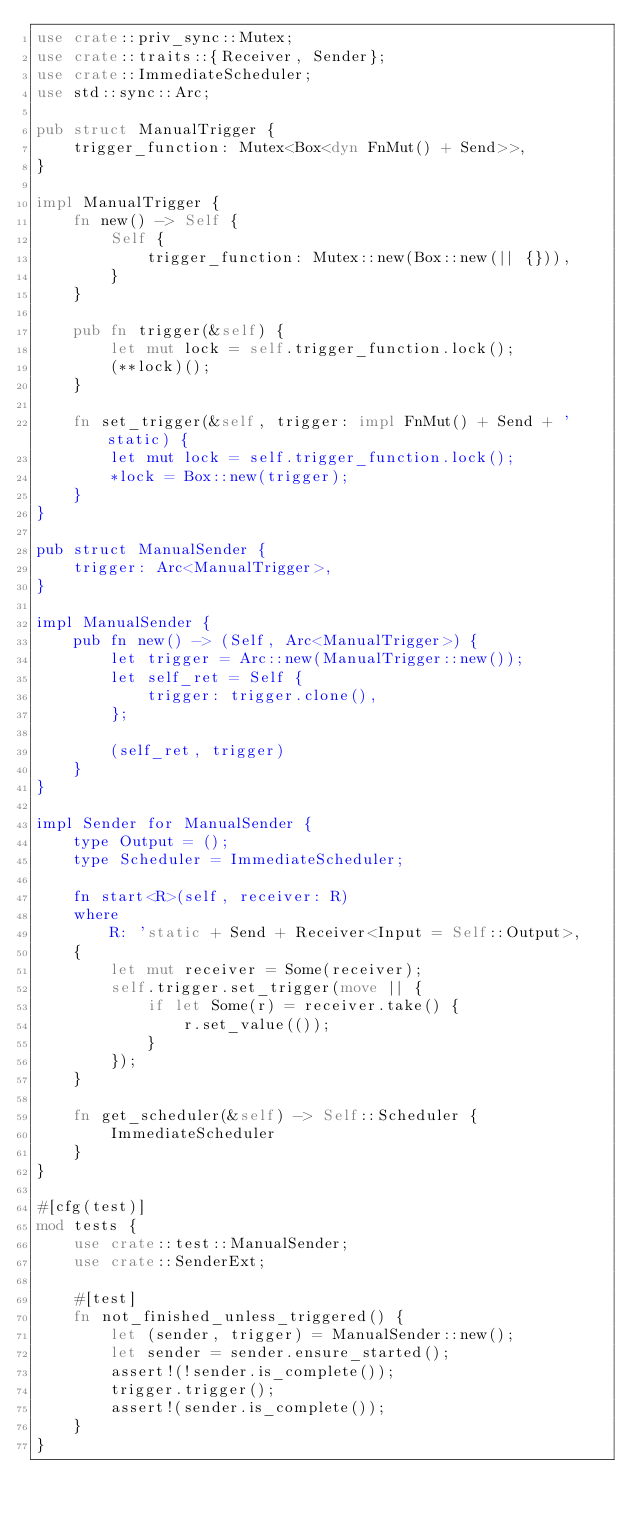Convert code to text. <code><loc_0><loc_0><loc_500><loc_500><_Rust_>use crate::priv_sync::Mutex;
use crate::traits::{Receiver, Sender};
use crate::ImmediateScheduler;
use std::sync::Arc;

pub struct ManualTrigger {
    trigger_function: Mutex<Box<dyn FnMut() + Send>>,
}

impl ManualTrigger {
    fn new() -> Self {
        Self {
            trigger_function: Mutex::new(Box::new(|| {})),
        }
    }

    pub fn trigger(&self) {
        let mut lock = self.trigger_function.lock();
        (**lock)();
    }

    fn set_trigger(&self, trigger: impl FnMut() + Send + 'static) {
        let mut lock = self.trigger_function.lock();
        *lock = Box::new(trigger);
    }
}

pub struct ManualSender {
    trigger: Arc<ManualTrigger>,
}

impl ManualSender {
    pub fn new() -> (Self, Arc<ManualTrigger>) {
        let trigger = Arc::new(ManualTrigger::new());
        let self_ret = Self {
            trigger: trigger.clone(),
        };

        (self_ret, trigger)
    }
}

impl Sender for ManualSender {
    type Output = ();
    type Scheduler = ImmediateScheduler;

    fn start<R>(self, receiver: R)
    where
        R: 'static + Send + Receiver<Input = Self::Output>,
    {
        let mut receiver = Some(receiver);
        self.trigger.set_trigger(move || {
            if let Some(r) = receiver.take() {
                r.set_value(());
            }
        });
    }

    fn get_scheduler(&self) -> Self::Scheduler {
        ImmediateScheduler
    }
}

#[cfg(test)]
mod tests {
    use crate::test::ManualSender;
    use crate::SenderExt;

    #[test]
    fn not_finished_unless_triggered() {
        let (sender, trigger) = ManualSender::new();
        let sender = sender.ensure_started();
        assert!(!sender.is_complete());
        trigger.trigger();
        assert!(sender.is_complete());
    }
}
</code> 